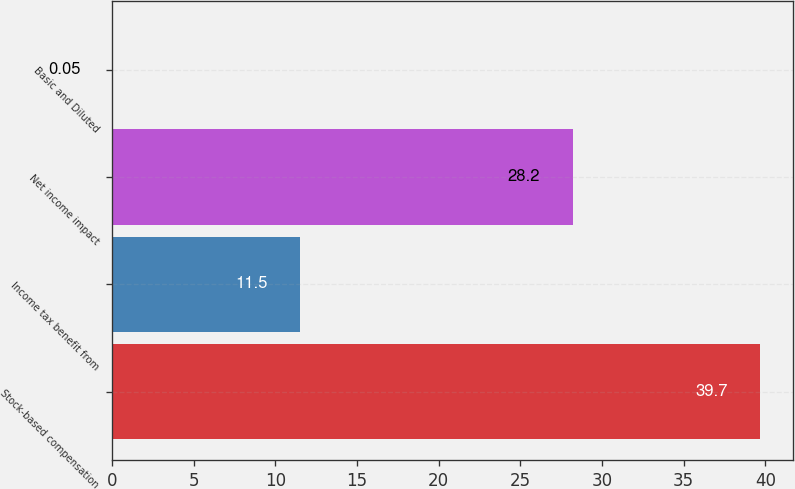<chart> <loc_0><loc_0><loc_500><loc_500><bar_chart><fcel>Stock-based compensation<fcel>Income tax benefit from<fcel>Net income impact<fcel>Basic and Diluted<nl><fcel>39.7<fcel>11.5<fcel>28.2<fcel>0.05<nl></chart> 